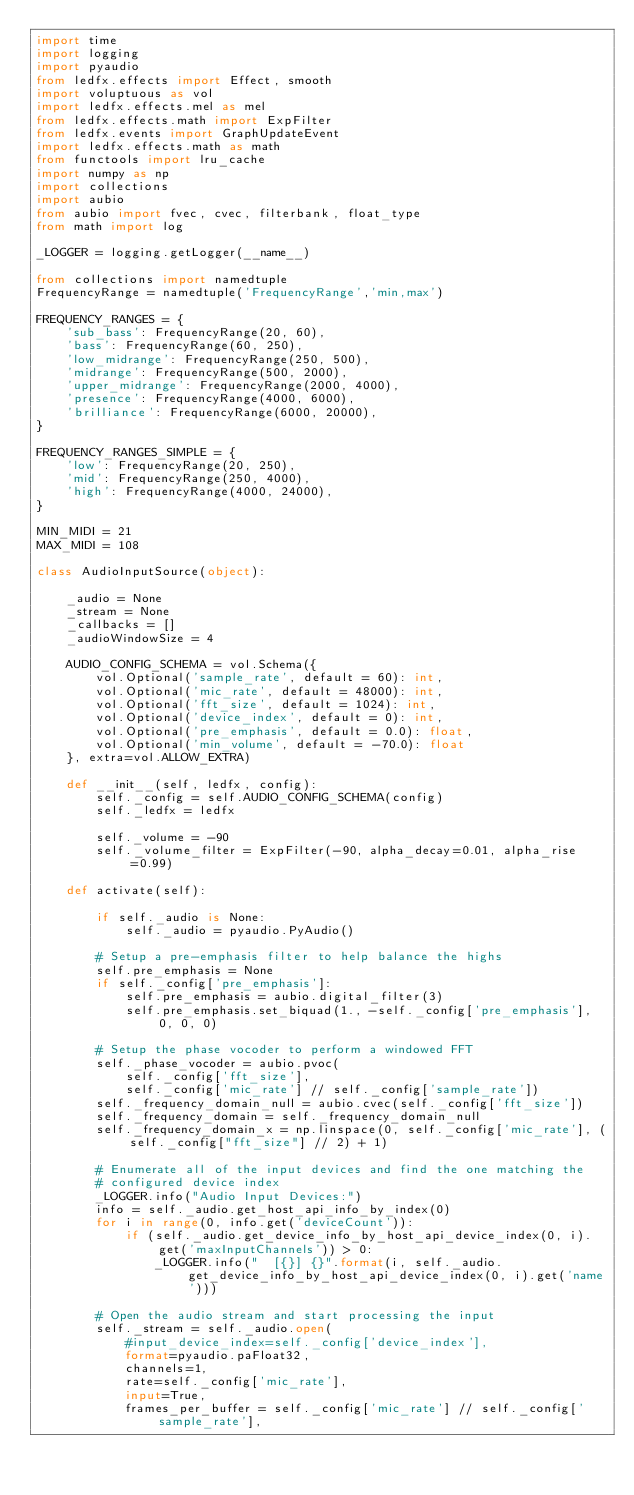<code> <loc_0><loc_0><loc_500><loc_500><_Python_>import time
import logging
import pyaudio
from ledfx.effects import Effect, smooth
import voluptuous as vol
import ledfx.effects.mel as mel
from ledfx.effects.math import ExpFilter
from ledfx.events import GraphUpdateEvent
import ledfx.effects.math as math
from functools import lru_cache
import numpy as np
import collections
import aubio
from aubio import fvec, cvec, filterbank, float_type
from math import log

_LOGGER = logging.getLogger(__name__)

from collections import namedtuple
FrequencyRange = namedtuple('FrequencyRange','min,max')

FREQUENCY_RANGES = {
    'sub_bass': FrequencyRange(20, 60),
    'bass': FrequencyRange(60, 250),
    'low_midrange': FrequencyRange(250, 500),
    'midrange': FrequencyRange(500, 2000),
    'upper_midrange': FrequencyRange(2000, 4000),
    'presence': FrequencyRange(4000, 6000),
    'brilliance': FrequencyRange(6000, 20000),
}

FREQUENCY_RANGES_SIMPLE = {
    'low': FrequencyRange(20, 250),
    'mid': FrequencyRange(250, 4000),
    'high': FrequencyRange(4000, 24000),
}

MIN_MIDI = 21
MAX_MIDI = 108

class AudioInputSource(object):

    _audio = None
    _stream = None
    _callbacks = []
    _audioWindowSize = 4

    AUDIO_CONFIG_SCHEMA = vol.Schema({
        vol.Optional('sample_rate', default = 60): int,
        vol.Optional('mic_rate', default = 48000): int,
        vol.Optional('fft_size', default = 1024): int,
        vol.Optional('device_index', default = 0): int,
        vol.Optional('pre_emphasis', default = 0.0): float,
        vol.Optional('min_volume', default = -70.0): float
    }, extra=vol.ALLOW_EXTRA)

    def __init__(self, ledfx, config):
        self._config = self.AUDIO_CONFIG_SCHEMA(config)
        self._ledfx = ledfx

        self._volume = -90
        self._volume_filter = ExpFilter(-90, alpha_decay=0.01, alpha_rise=0.99)

    def activate(self):

        if self._audio is None:
            self._audio = pyaudio.PyAudio()

        # Setup a pre-emphasis filter to help balance the highs
        self.pre_emphasis = None
        if self._config['pre_emphasis']:
            self.pre_emphasis = aubio.digital_filter(3)
            self.pre_emphasis.set_biquad(1., -self._config['pre_emphasis'], 0, 0, 0)

        # Setup the phase vocoder to perform a windowed FFT
        self._phase_vocoder = aubio.pvoc(
            self._config['fft_size'], 
            self._config['mic_rate'] // self._config['sample_rate'])
        self._frequency_domain_null = aubio.cvec(self._config['fft_size'])
        self._frequency_domain = self._frequency_domain_null
        self._frequency_domain_x = np.linspace(0, self._config['mic_rate'], (self._config["fft_size"] // 2) + 1)

        # Enumerate all of the input devices and find the one matching the
        # configured device index
        _LOGGER.info("Audio Input Devices:")
        info = self._audio.get_host_api_info_by_index(0)
        for i in range(0, info.get('deviceCount')):
            if (self._audio.get_device_info_by_host_api_device_index(0, i).get('maxInputChannels')) > 0:
                _LOGGER.info("  [{}] {}".format(i, self._audio.get_device_info_by_host_api_device_index(0, i).get('name')))

        # Open the audio stream and start processing the input
        self._stream = self._audio.open(
            #input_device_index=self._config['device_index'],
            format=pyaudio.paFloat32,
            channels=1,
            rate=self._config['mic_rate'],
            input=True,
            frames_per_buffer = self._config['mic_rate'] // self._config['sample_rate'],</code> 